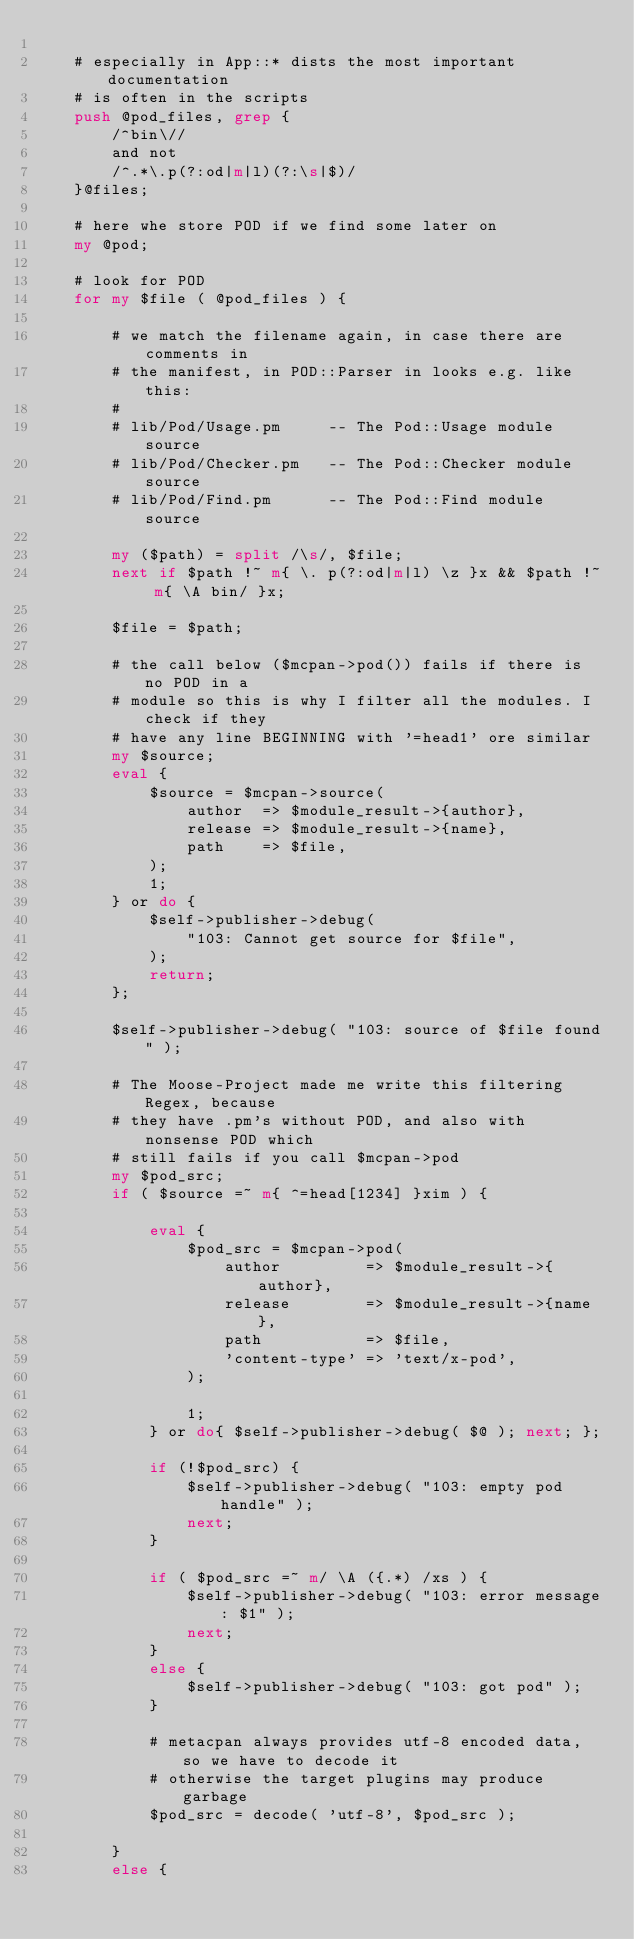Convert code to text. <code><loc_0><loc_0><loc_500><loc_500><_Perl_>
    # especially in App::* dists the most important documentation
    # is often in the scripts
    push @pod_files, grep {
        /^bin\//
        and not
        /^.*\.p(?:od|m|l)(?:\s|$)/
    }@files;

    # here whe store POD if we find some later on
    my @pod;

    # look for POD
    for my $file ( @pod_files ) {

        # we match the filename again, in case there are comments in
        # the manifest, in POD::Parser in looks e.g. like this:
        #
        # lib/Pod/Usage.pm     -- The Pod::Usage module source
        # lib/Pod/Checker.pm   -- The Pod::Checker module source
        # lib/Pod/Find.pm      -- The Pod::Find module source

        my ($path) = split /\s/, $file;
        next if $path !~ m{ \. p(?:od|m|l) \z }x && $path !~ m{ \A bin/ }x;

        $file = $path;

        # the call below ($mcpan->pod()) fails if there is no POD in a
        # module so this is why I filter all the modules. I check if they
        # have any line BEGINNING with '=head1' ore similar
        my $source;
        eval {
            $source = $mcpan->source(
                author  => $module_result->{author},
                release => $module_result->{name},
                path    => $file,
            );
            1;
        } or do {
            $self->publisher->debug(
                "103: Cannot get source for $file",
            );
            return;
        };

        $self->publisher->debug( "103: source of $file found" );

        # The Moose-Project made me write this filtering Regex, because
        # they have .pm's without POD, and also with nonsense POD which
        # still fails if you call $mcpan->pod
        my $pod_src;
        if ( $source =~ m{ ^=head[1234] }xim ) {

            eval {
                $pod_src = $mcpan->pod(
                    author         => $module_result->{author},
                    release        => $module_result->{name},
                    path           => $file,
                    'content-type' => 'text/x-pod',
                );

                1;
            } or do{ $self->publisher->debug( $@ ); next; };

            if (!$pod_src) {
                $self->publisher->debug( "103: empty pod handle" );
                next;
            }

            if ( $pod_src =~ m/ \A ({.*) /xs ) {
                $self->publisher->debug( "103: error message: $1" );
                next;
            }
            else {
                $self->publisher->debug( "103: got pod" );
            }

            # metacpan always provides utf-8 encoded data, so we have to decode it
            # otherwise the target plugins may produce garbage
            $pod_src = decode( 'utf-8', $pod_src );

        }
        else {</code> 